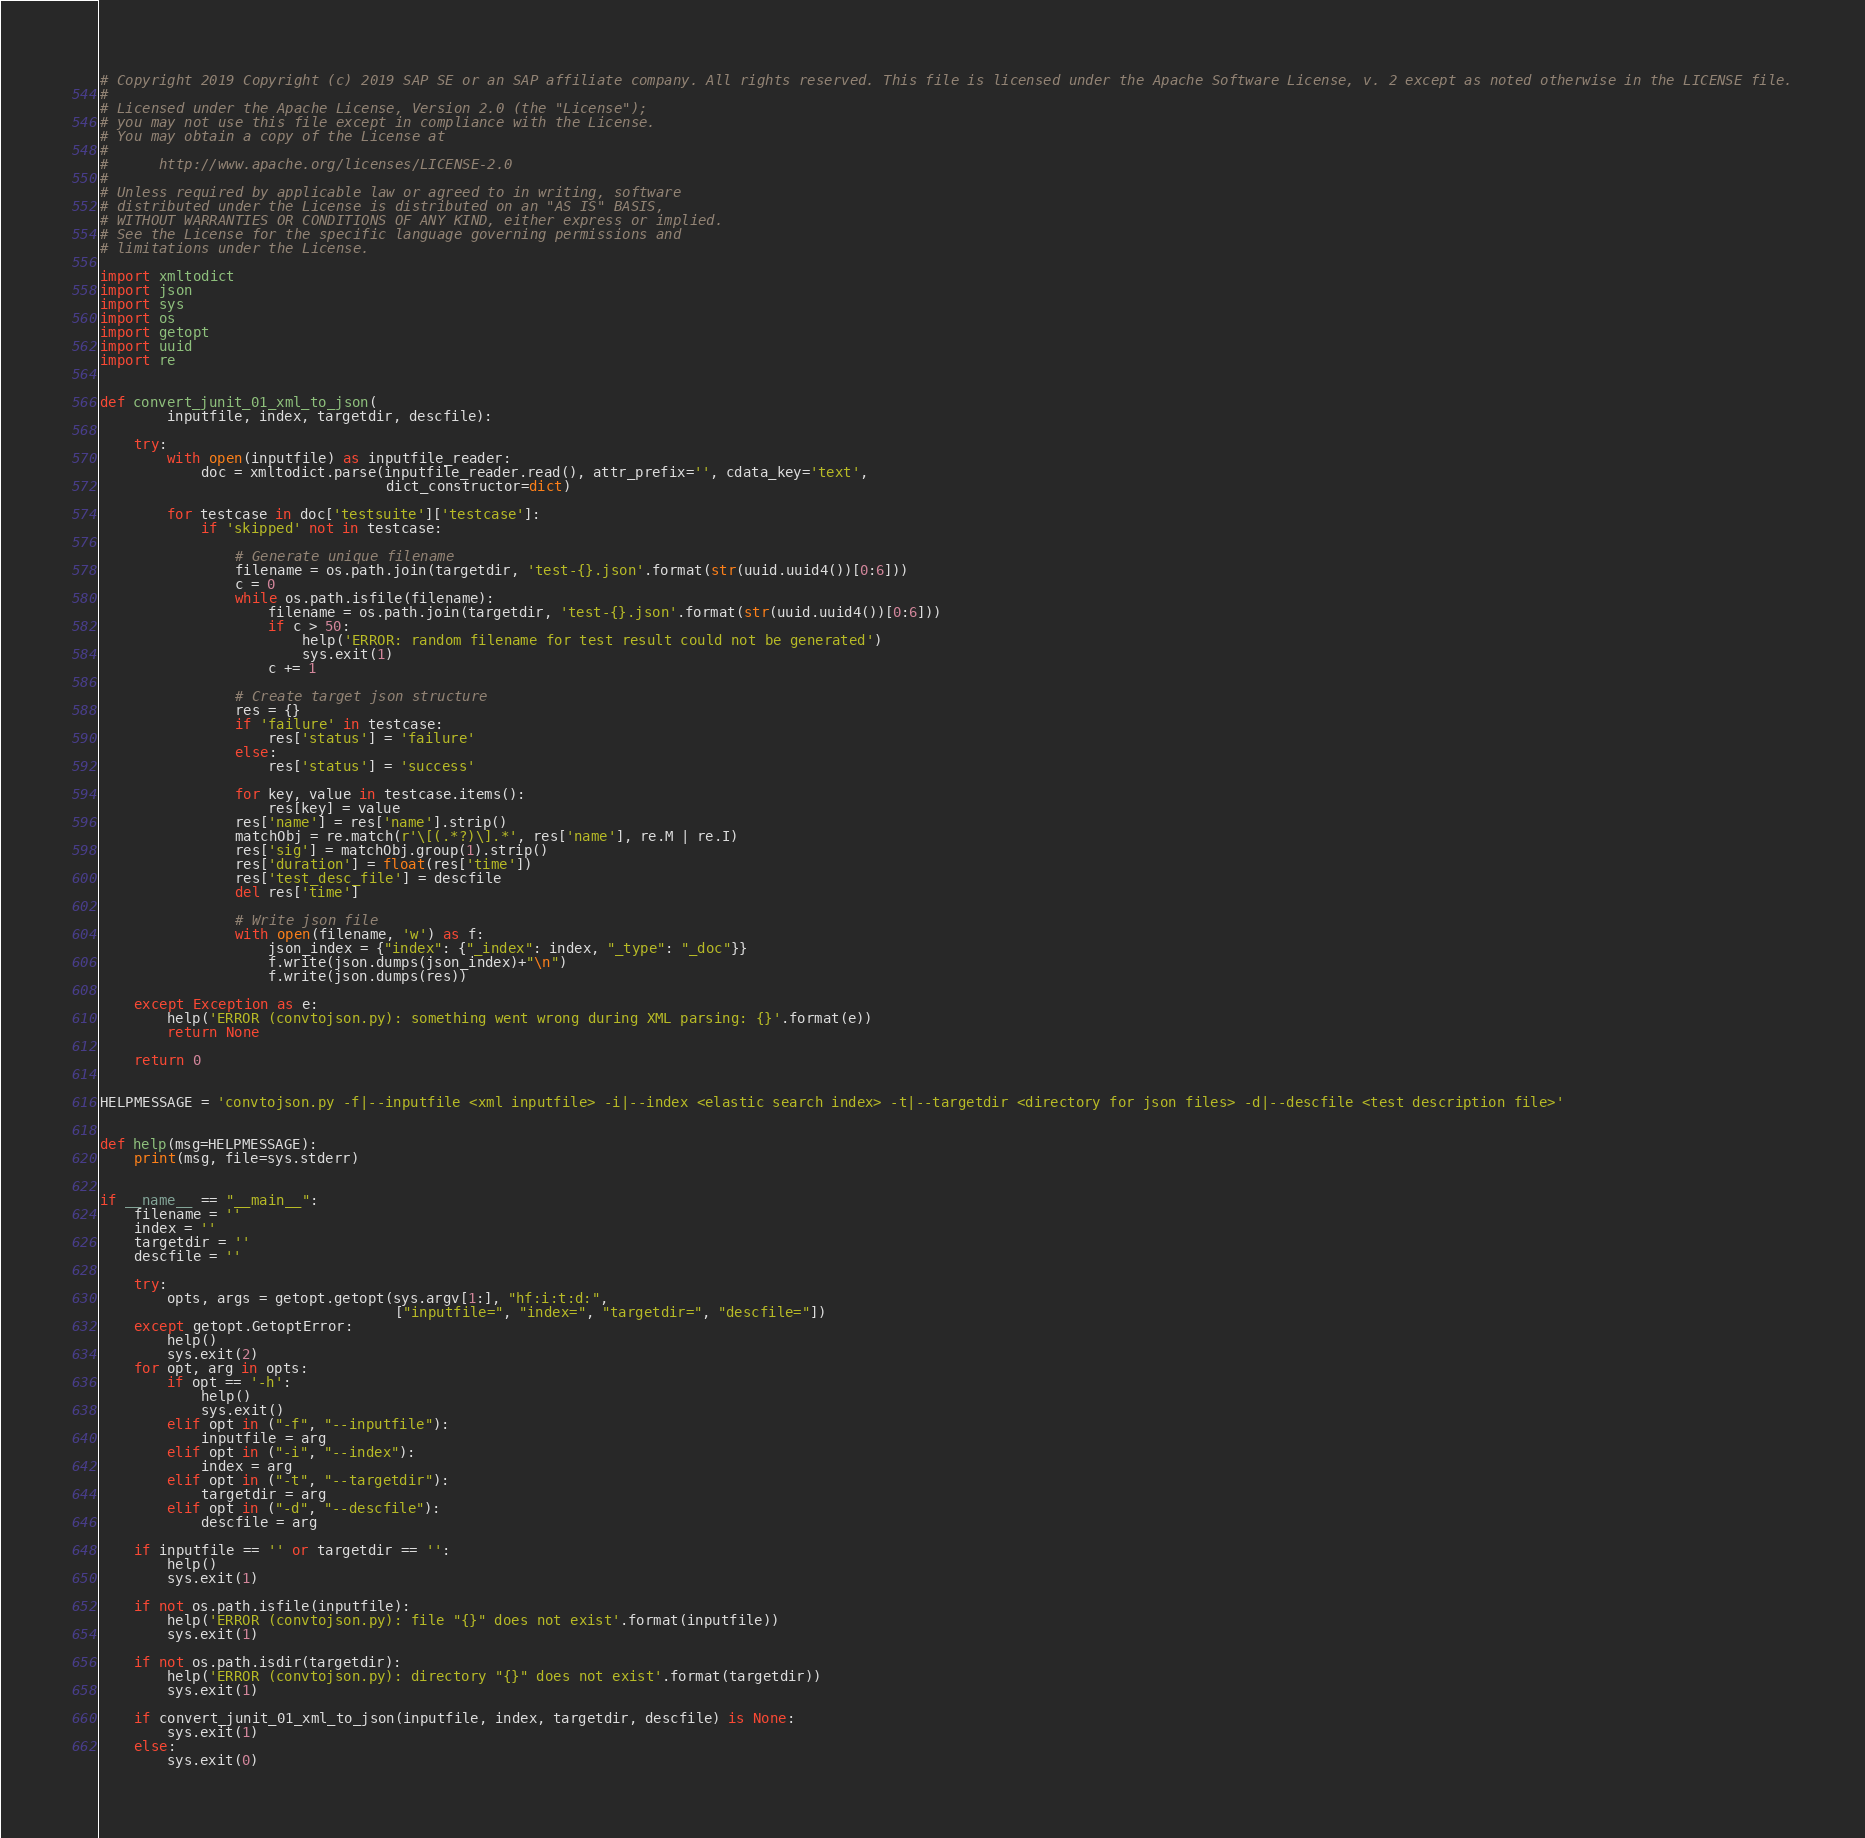<code> <loc_0><loc_0><loc_500><loc_500><_Python_># Copyright 2019 Copyright (c) 2019 SAP SE or an SAP affiliate company. All rights reserved. This file is licensed under the Apache Software License, v. 2 except as noted otherwise in the LICENSE file.
#
# Licensed under the Apache License, Version 2.0 (the "License");
# you may not use this file except in compliance with the License.
# You may obtain a copy of the License at
#
#      http://www.apache.org/licenses/LICENSE-2.0
#
# Unless required by applicable law or agreed to in writing, software
# distributed under the License is distributed on an "AS IS" BASIS,
# WITHOUT WARRANTIES OR CONDITIONS OF ANY KIND, either express or implied.
# See the License for the specific language governing permissions and
# limitations under the License.

import xmltodict
import json
import sys
import os
import getopt
import uuid
import re


def convert_junit_01_xml_to_json(
        inputfile, index, targetdir, descfile):

    try:
        with open(inputfile) as inputfile_reader:
            doc = xmltodict.parse(inputfile_reader.read(), attr_prefix='', cdata_key='text',
                                  dict_constructor=dict)

        for testcase in doc['testsuite']['testcase']:
            if 'skipped' not in testcase:

                # Generate unique filename
                filename = os.path.join(targetdir, 'test-{}.json'.format(str(uuid.uuid4())[0:6]))
                c = 0
                while os.path.isfile(filename):
                    filename = os.path.join(targetdir, 'test-{}.json'.format(str(uuid.uuid4())[0:6]))
                    if c > 50:
                        help('ERROR: random filename for test result could not be generated')
                        sys.exit(1)
                    c += 1

                # Create target json structure
                res = {}
                if 'failure' in testcase:
                    res['status'] = 'failure'
                else:
                    res['status'] = 'success'

                for key, value in testcase.items():
                    res[key] = value
                res['name'] = res['name'].strip()
                matchObj = re.match(r'\[(.*?)\].*', res['name'], re.M | re.I)
                res['sig'] = matchObj.group(1).strip()
                res['duration'] = float(res['time'])
                res['test_desc_file'] = descfile
                del res['time']

                # Write json file
                with open(filename, 'w') as f:
                    json_index = {"index": {"_index": index, "_type": "_doc"}}
                    f.write(json.dumps(json_index)+"\n")
                    f.write(json.dumps(res))

    except Exception as e:
        help('ERROR (convtojson.py): something went wrong during XML parsing: {}'.format(e))
        return None

    return 0


HELPMESSAGE = 'convtojson.py -f|--inputfile <xml inputfile> -i|--index <elastic search index> -t|--targetdir <directory for json files> -d|--descfile <test description file>'


def help(msg=HELPMESSAGE):
    print(msg, file=sys.stderr)


if __name__ == "__main__":
    filename = ''
    index = ''
    targetdir = ''
    descfile = ''

    try:
        opts, args = getopt.getopt(sys.argv[1:], "hf:i:t:d:",
                                   ["inputfile=", "index=", "targetdir=", "descfile="])
    except getopt.GetoptError:
        help()
        sys.exit(2)
    for opt, arg in opts:
        if opt == '-h':
            help()
            sys.exit()
        elif opt in ("-f", "--inputfile"):
            inputfile = arg
        elif opt in ("-i", "--index"):
            index = arg
        elif opt in ("-t", "--targetdir"):
            targetdir = arg
        elif opt in ("-d", "--descfile"):
            descfile = arg

    if inputfile == '' or targetdir == '':
        help()
        sys.exit(1)

    if not os.path.isfile(inputfile):
        help('ERROR (convtojson.py): file "{}" does not exist'.format(inputfile))
        sys.exit(1)

    if not os.path.isdir(targetdir):
        help('ERROR (convtojson.py): directory "{}" does not exist'.format(targetdir))
        sys.exit(1)

    if convert_junit_01_xml_to_json(inputfile, index, targetdir, descfile) is None:
        sys.exit(1)
    else:
        sys.exit(0)
</code> 